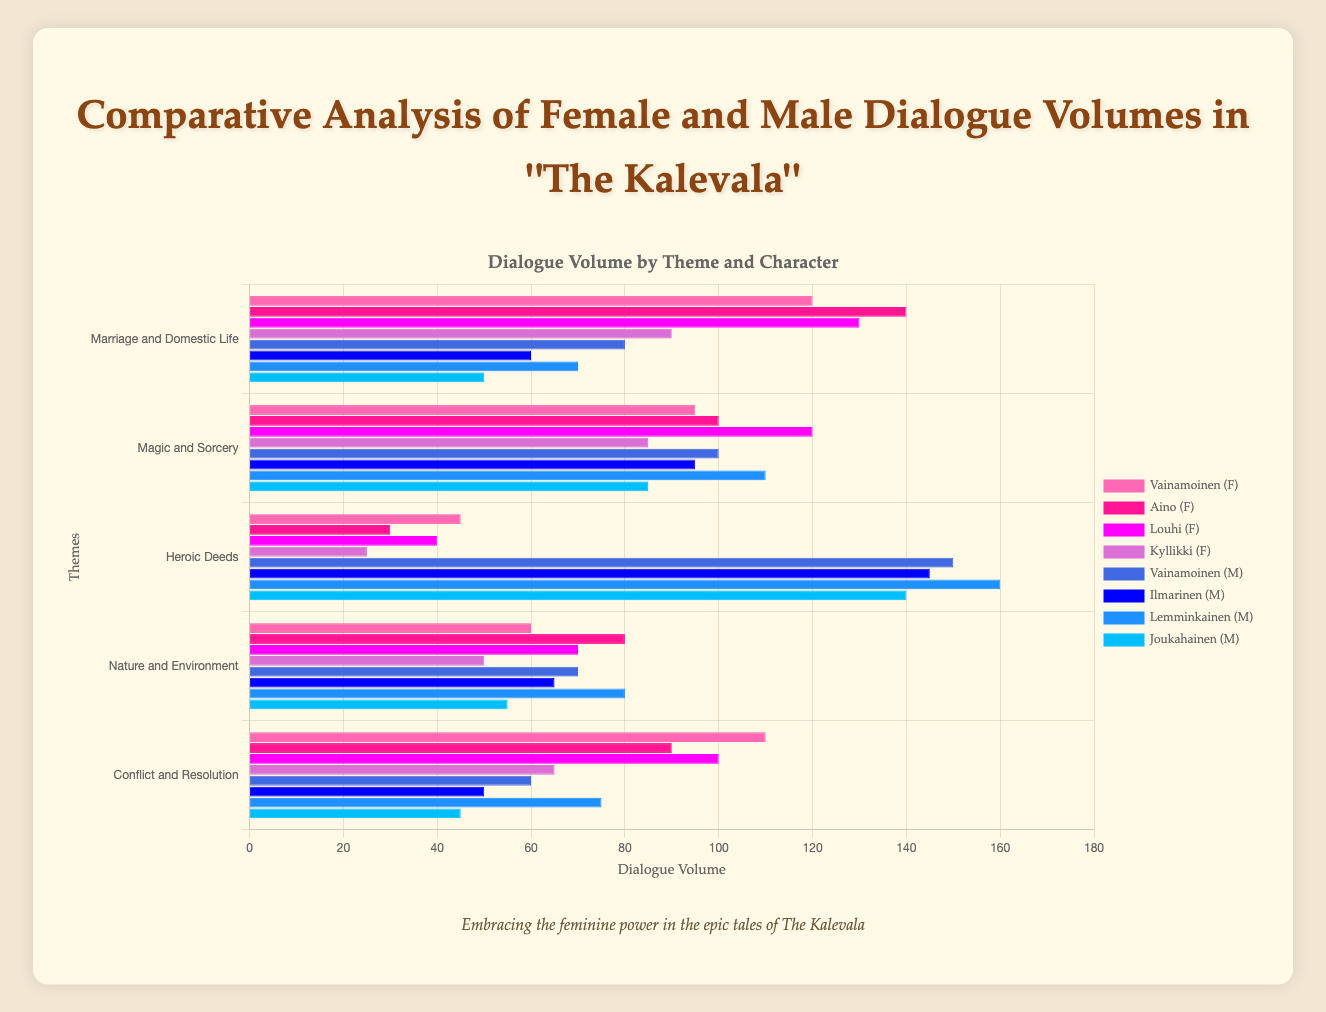Which character has the highest volume of female dialogue in the theme "Magic and Sorcery"? Aino's female dialogue volume for "Magic and Sorcery" is 100, which is higher than all other female characters in that theme.
Answer: Aino Who speaks more about "Marriage and Domestic Life", Louhi or Vainamoinen? Louhi has a female dialogue volume of 130, whereas Vainamoinen has a male dialogue volume of 80 for the theme "Marriage and Domestic Life". Louhi speaks more.
Answer: Louhi Which theme has the highest combined dialogue volume for all characters (female and male)? Add all the dialogue volumes for each character for each theme. The calculations are: 
"Marriage and Domestic Life": 120+140+130+90+80+60+70+50 = 740 
"Magic and Sorcery": 95+100+120+85+100+95+110+85 = 790 
"Heroic Deeds": 45+30+40+25+150+145+160+140 = 735 
"Nature and Environment": 60+80+70+50+70+65+80+55 = 530 
"Conflict and Resolution": 110+90+100+65+60+50+75+45 = 595 
"Magic and Sorcery" has the highest combined dialogue volume (790).
Answer: Magic and Sorcery How does Kyllikki's dialogue volume for "Heroic Deeds" compare to Lemminkainen's? Kyllikki has a female dialogue volume of 25, while Lemminkainen has a male dialogue volume of 160 for the theme "Heroic Deeds". Lemminkainen has significantly more dialogue volume.
Answer: Lemminkainen Is there any female character who has a higher dialogue volume in "Nature and Environment" than the highest male speaker in the same theme? Louhi has the highest female dialogue volume for "Nature and Environment" at 70, whereas Lemminkainen, the highest male speaker, has a volume of 80. No female character has a higher volume than Lemminkainen for this theme.
Answer: No What is the total dialogue volume for Vainamoinen (both female and male) across all themes? Sum the dialogue volumes for Vainamoinen: 
Female: 120+95+45+60+110 = 430 
Male: 80+100+150+70+60 = 460 
Total: 430+460 = 890
Answer: 890 Which male character has the least dialogue volume in "Conflict and Resolution"? Joukahainen has the least male dialogue volume for "Conflict and Resolution" with 45, compared to Vainamoinen (60), Ilmarinen (50), and Lemminkainen (75).
Answer: Joukahainen For the theme "Heroic Deeds", how does the total female dialogue volume compare to the total male dialogue volume? Sum the dialogue volumes for each gender: 
Female: 45+30+40+25 = 140 
Male: 150+145+160+140 = 595 
The total male dialogue volume (595) is significantly higher than the total female dialogue volume (140) for "Heroic Deeds".
Answer: Male dialogue is higher Which theme has the smallest difference in dialogue volume between the highest female and male speakers? Calculate the differences for each theme: 
"Marriage and Domestic Life": Louhi (130) - Vainamoinen (80) = 50 
"Magic and Sorcery": Louhi (120) - Lemminkainen (110) = 10 
"Heroic Deeds": Louhi (40) - Lemminkainen (160) = 120 
"Nature and Environment": Aino (80) - Lemminkainen (80) = 0 
"Conflict and Resolution": Louhi (100) - Lemminkainen (75) = 25 
The smallest difference is for "Nature and Environment" with a difference of 0; both Aino and Lemminkainen have the same volume of 80.
Answer: Nature and Environment Who dominates the dialogue volume in the theme "Conflict and Resolution"? Louhi has the highest female dialogue volume with 100, which is higher than the male speakers: Vainamoinen (60), Ilmarinen (50), Lemminkainen (75), and Joukahainen (45). Louhi dominates this theme.
Answer: Louhi 